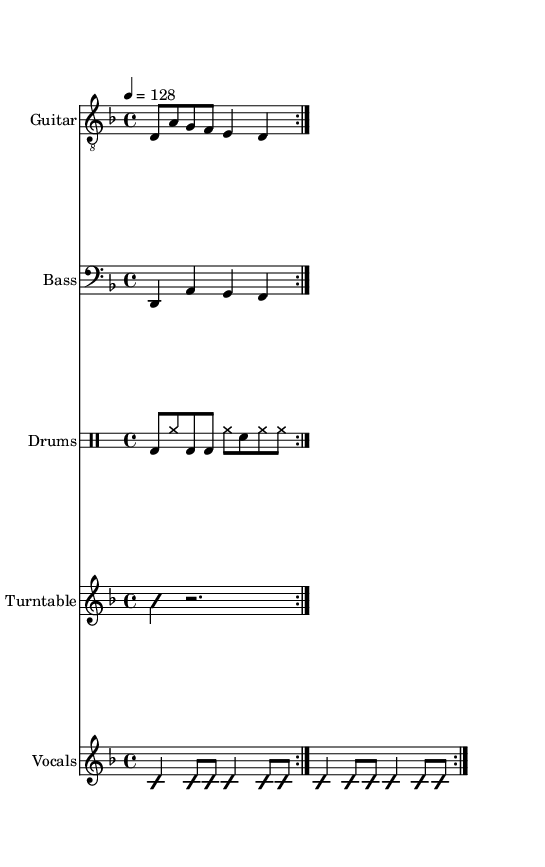What is the key signature of this music? The key signature is indicated by the absence of sharps or flats, and it is confirmed as D minor with the note D being the tonic.
Answer: D minor What is the time signature of this music? The time signature is found at the beginning of the music, indicated by the notation "4/4", which signifies four beats in each measure.
Answer: 4/4 What is the tempo marking of this piece? The tempo marking is given by the instruction "4 = 128," indicating that there are 128 beats per minute.
Answer: 128 How many measures are repeated for the vocal melody? The vocal melody contains a repeated structure as indicated by the "repeat volta 2" marking, meaning it is played twice.
Answer: 2 What genre does this piece represent? The instrumentation, stylistic choice, and lyrical themes in the score suggest elements characteristic of Nu Metal, particularly the blending of heavy guitar riffs with hip-hop influences.
Answer: Nu Metal Which instrument is primarily responsible for the rhythm in this piece? The rhythm is driven primarily by the drum part, which is indicated by the distinct drum pattern written in the drummode notation, providing the backbone for the other instruments.
Answer: Drums What role does the turntable play in this composition? The turntable part is notated as an improvisational section, suggesting its role to add a unique texture and contribute to the overall feel of Nu Metal, often used to create scratches and samples.
Answer: Improvisational texture 